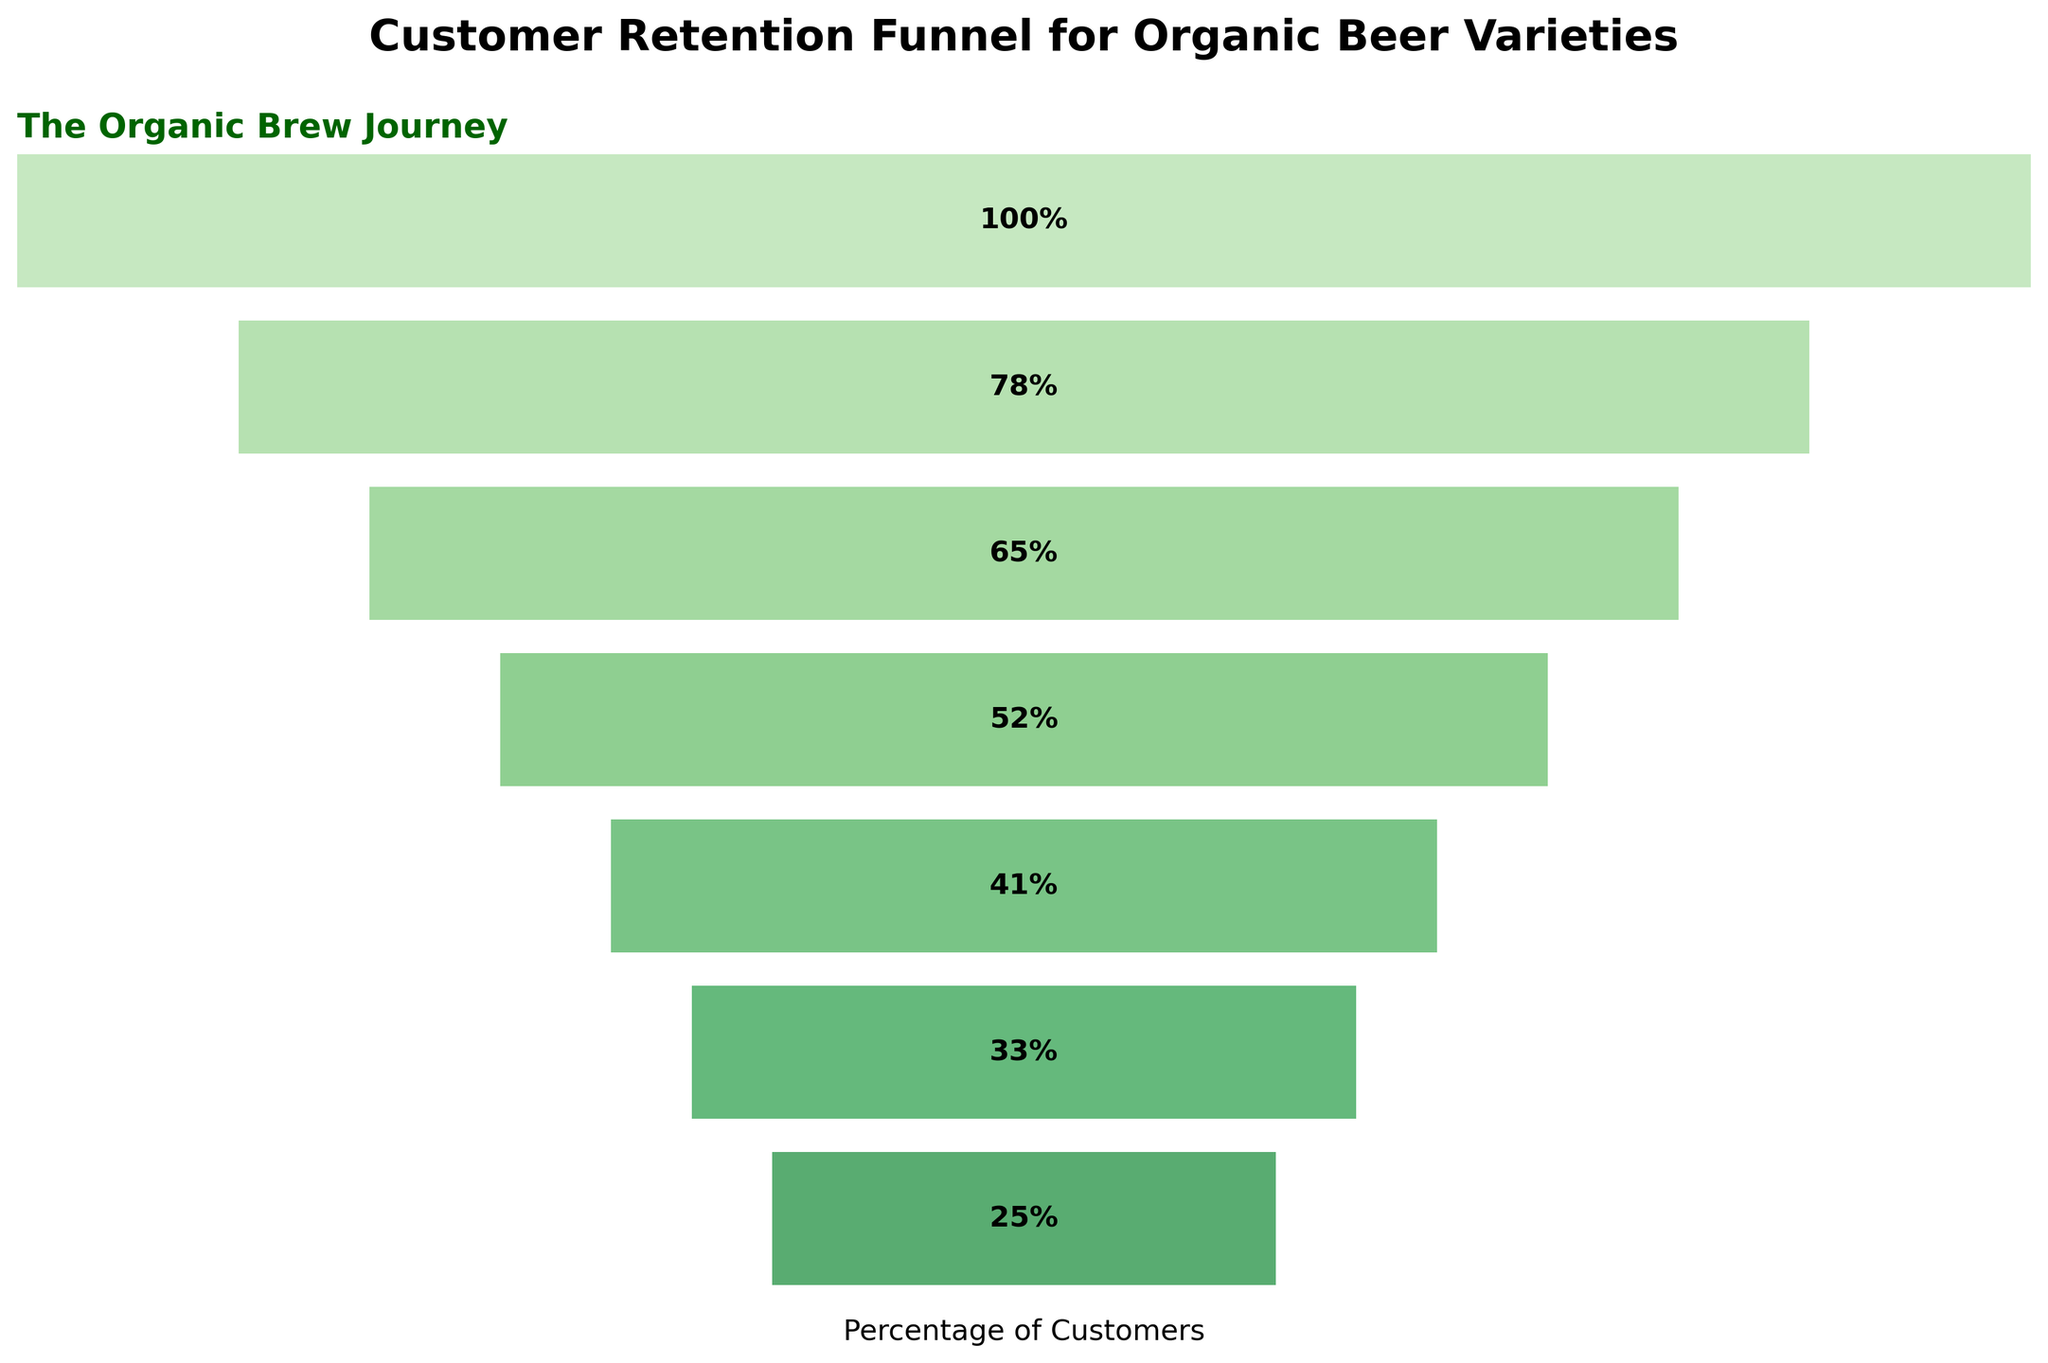What is the title of the chart? The title is located at the top of the chart and it summarizes the main topic of the figure.
Answer: Customer Retention Funnel for Organic Beer Varieties Which two stages have the largest customer retention rate difference? Find the two stages with the highest numerical customer retention rate difference by subtracting the lower percentage from the higher one for each consecutive stage.
Answer: Initial Purchase and Repeat Purchase - Organic IPA What is the retention rate of Loyal Customer for Organic Wheat Beer? Locate the stage labeled "Loyal Customer - Organic Wheat Beer" and read the retention rate percentage next to it.
Answer: 25% Which beer variety has the highest retention rate at the Loyal Customer stage? Compare the retention rates at the Loyal Customer stage across Organic IPA, Organic Pilsner, and Organic Wheat Beer. The highest percentage indicates the beer variety with the highest retention rate.
Answer: Organic IPA What is the difference in retention rates between Repeat Purchase and Loyal Customer for Organic Pilsner? Find the retention rates for "Repeat Purchase - Organic Pilsner" and "Loyal Customer - Organic Pilsner" and subtract the latter from the former. 65% - 33% = 32%.
Answer: 32% How does the retention rate change from Initial Purchase to Loyal Customer for Organic IPA? Extract the retention rates for "Initial Purchase," "Repeat Purchase - Organic IPA," and "Loyal Customer - Organic IPA" and outline the decrease in percentage: 100% -> 78% -> 41%.
Answer: Declines from 100% to 78% to 41% What is the overall trend observed in the retention rates from Initial Purchase to Loyal Customers? The retention rate plot starts from the highest at "Initial Purchase", then gradually decreases at each subsequent stage.
Answer: Generally decreasing How many percentage points higher is the retention rate for Repeat Purchase than for Loyal Customer in Organic Wheat Beer? Extract the retention rates for "Repeat Purchase - Organic Wheat Beer" and "Loyal Customer - Organic Wheat Beer" and subtract the latter from the former. 52% - 25% = 27%.
Answer: 27% Which stage shows the greatest loss in retention rate for Organic IPA? Analyze the retention rate drop between each stage for Organic IPA: Initial Purchase -> Repeat Purchase (100% to 78%) and Repeat Purchase -> Loyal Customer (78% to 41%), 100% to 78% (22%) is higher.
Answer: Repeat Purchase Compare the retention rates for Initial Purchase and Repeat Purchase - Organic Pilsner. Which one is higher and by how much? Extract the retention rates for "Initial Purchase" and "Repeat Purchase - Organic Pilsner" and calculate the difference. 100% - 65% = 35%.
Answer: Initial Purchase by 35% 